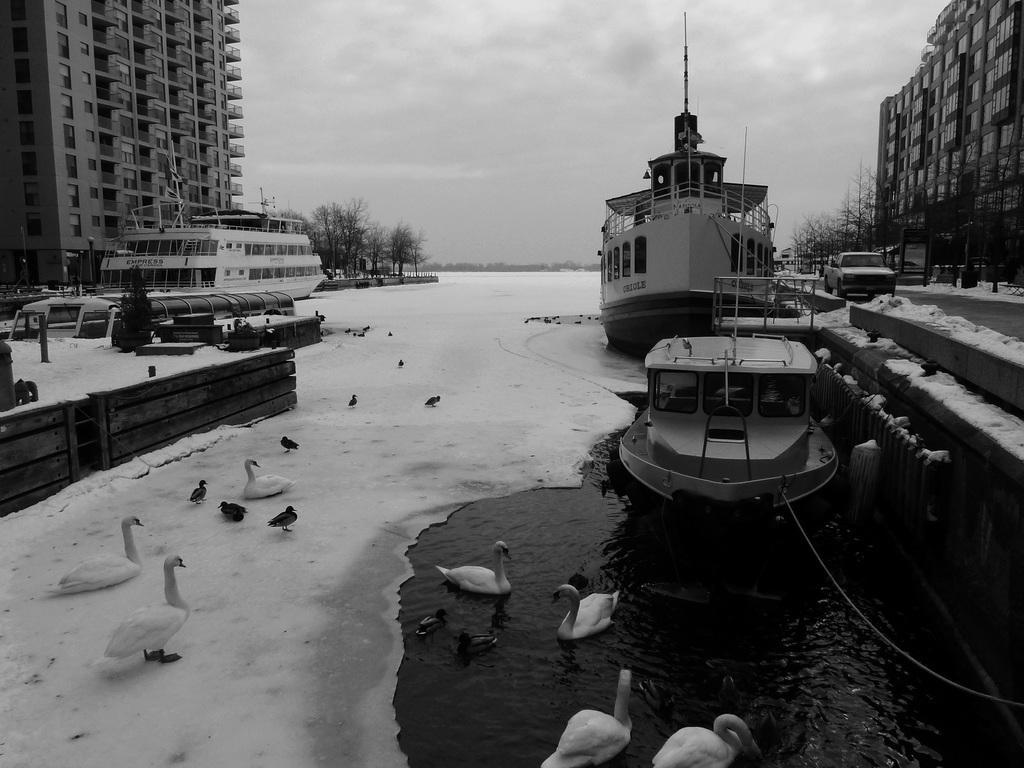Can you describe this image briefly? In this picture I can see the water in front and I can also see number of ducks and boats and I can see buildings and trees on both the sides. On the right side of this picture I can see the road on which there is a car. In the background I can see the sky which is a bit cloudy. I see that this is a black and white picture. 